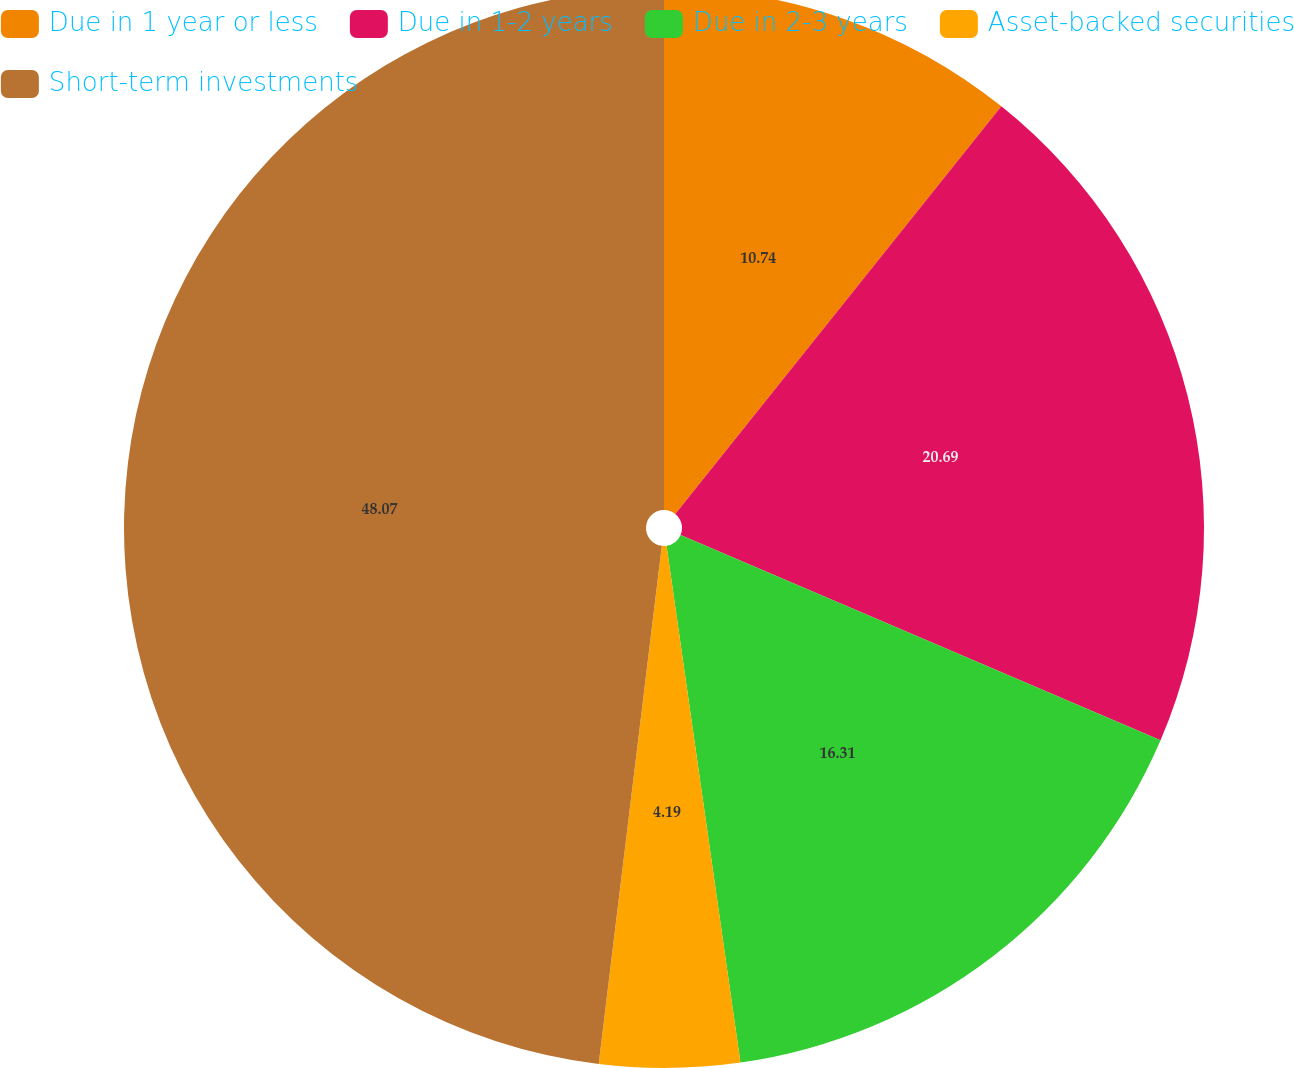Convert chart. <chart><loc_0><loc_0><loc_500><loc_500><pie_chart><fcel>Due in 1 year or less<fcel>Due in 1-2 years<fcel>Due in 2-3 years<fcel>Asset-backed securities<fcel>Short-term investments<nl><fcel>10.74%<fcel>20.69%<fcel>16.31%<fcel>4.19%<fcel>48.07%<nl></chart> 